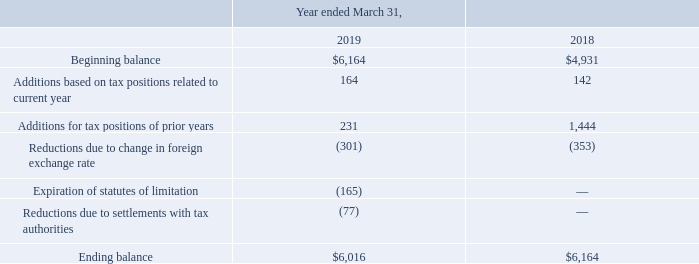A reconciliation of the beginning and ending amount of unrecognized tax benefits is as follows:
Interest and penalty charges, if any, related to uncertain tax positions are classified as income tax expense in the accompanying consolidated statements of operations. As of March 31, 2019 and 2018, the Company had immaterial accrued interest or penalties related to uncertain tax positions.
The Company is subject to taxation in the United Kingdom and several foreign jurisdictions. As of March 31, 2019, the Company is no longer subject to examination by taxing authorities in the United Kingdom for years prior to March 31, 2017. The significant foreign jurisdictions in which the Company operates are no longer subject to examination by taxing authorities for years prior to March 31, 2016. In addition, net operating loss carryforwards in certain jurisdictions may be subject to adjustments by taxing authorities in future years when they are utilized.
The Company had approximately $24.9 million of unremitted foreign earnings as of March 31, 2019. Income taxes have been provided on approximately $10.0 million of the unremitted foreign earnings. Income taxes have not been provided on approximately $14.9 million of unremitted foreign earnings because they are considered to be indefinitely reinvested. The tax payable on the earnings that are indefinitely reinvested would be immaterial.
What was the Beginning balance in 2019 and 2018 respectively? $6,164, $4,931. What was the ending balance in 2019 and 2018 respectively? $6,016, $6,164. What was the Additions based on tax positions related to current year in 2019 and 2018 respectively? 164, 142. What was the change in the Beginning balance from 2018 to 2019? 6,164 - 4,931
Answer: 1233. What was the average Additions for tax positions of prior years for 2018 and 2019? (231 + 1,444) / 2
Answer: 837.5. In which year was Expiration of statutes of limitation less than 0? Locate and analyze expiration of statutes of limitation in row 7
answer: 2019. 